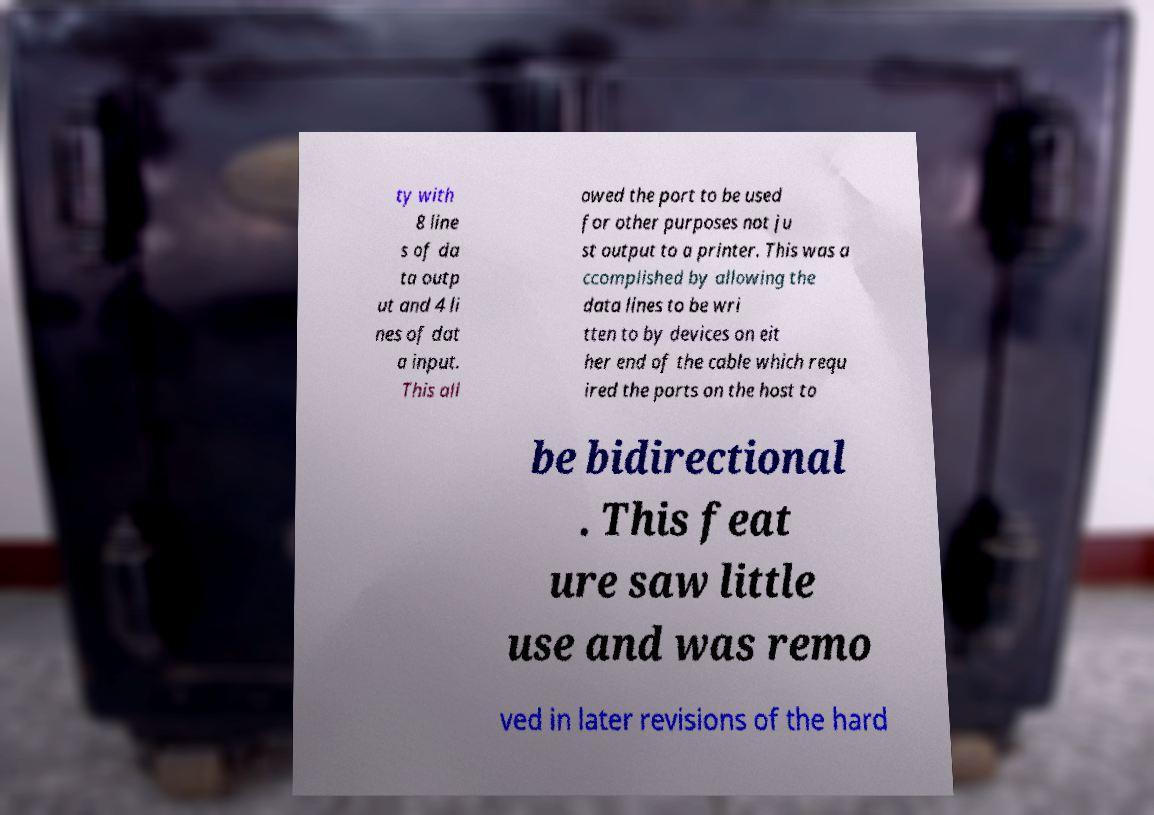I need the written content from this picture converted into text. Can you do that? ty with 8 line s of da ta outp ut and 4 li nes of dat a input. This all owed the port to be used for other purposes not ju st output to a printer. This was a ccomplished by allowing the data lines to be wri tten to by devices on eit her end of the cable which requ ired the ports on the host to be bidirectional . This feat ure saw little use and was remo ved in later revisions of the hard 